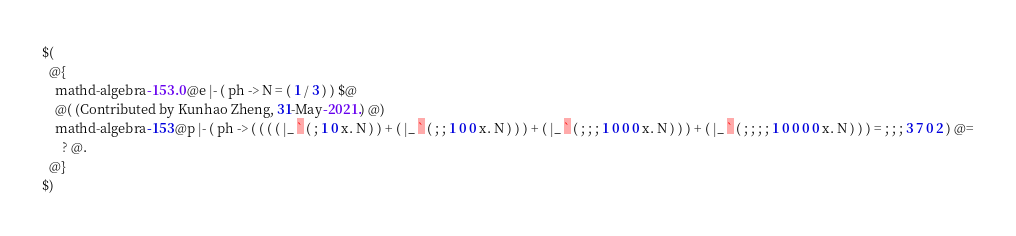<code> <loc_0><loc_0><loc_500><loc_500><_ObjectiveC_>$(
  @{
    mathd-algebra-153.0 @e |- ( ph -> N = ( 1 / 3 ) ) $@
    @( (Contributed by Kunhao Zheng, 31-May-2021.) @)
    mathd-algebra-153 @p |- ( ph -> ( ( ( ( |_ ` ( ; 1 0 x. N ) ) + ( |_ ` ( ; ; 1 0 0 x. N ) ) ) + ( |_ ` ( ; ; ; 1 0 0 0 x. N ) ) ) + ( |_ ` ( ; ; ; ; 1 0 0 0 0 x. N ) ) ) = ; ; ; 3 7 0 2 ) @=
      ? @.
  @}
$)
</code> 